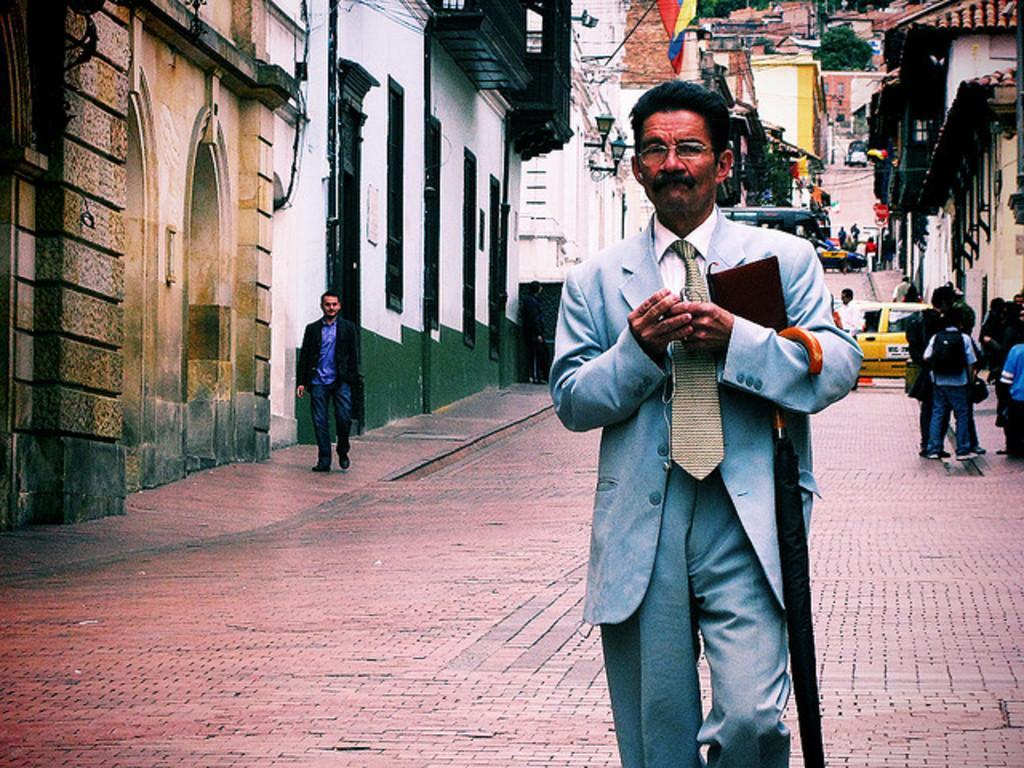Please provide a concise description of this image. In this picture we can see group of people, in the middle of the image we can see a man, he is holding an umbrella and a book, in the background we can find few buildings, trees, vehicles and lights. 